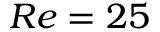<formula> <loc_0><loc_0><loc_500><loc_500>R e = 2 5</formula> 